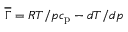<formula> <loc_0><loc_0><loc_500><loc_500>\overline { \Gamma } = R T / p c _ { p } - d T / d p</formula> 